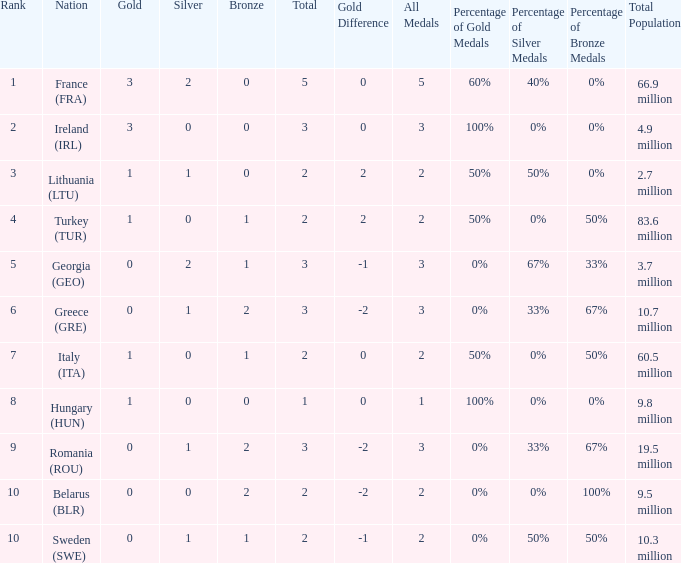What's the total when the gold is less than 0 and silver is less than 1? None. 